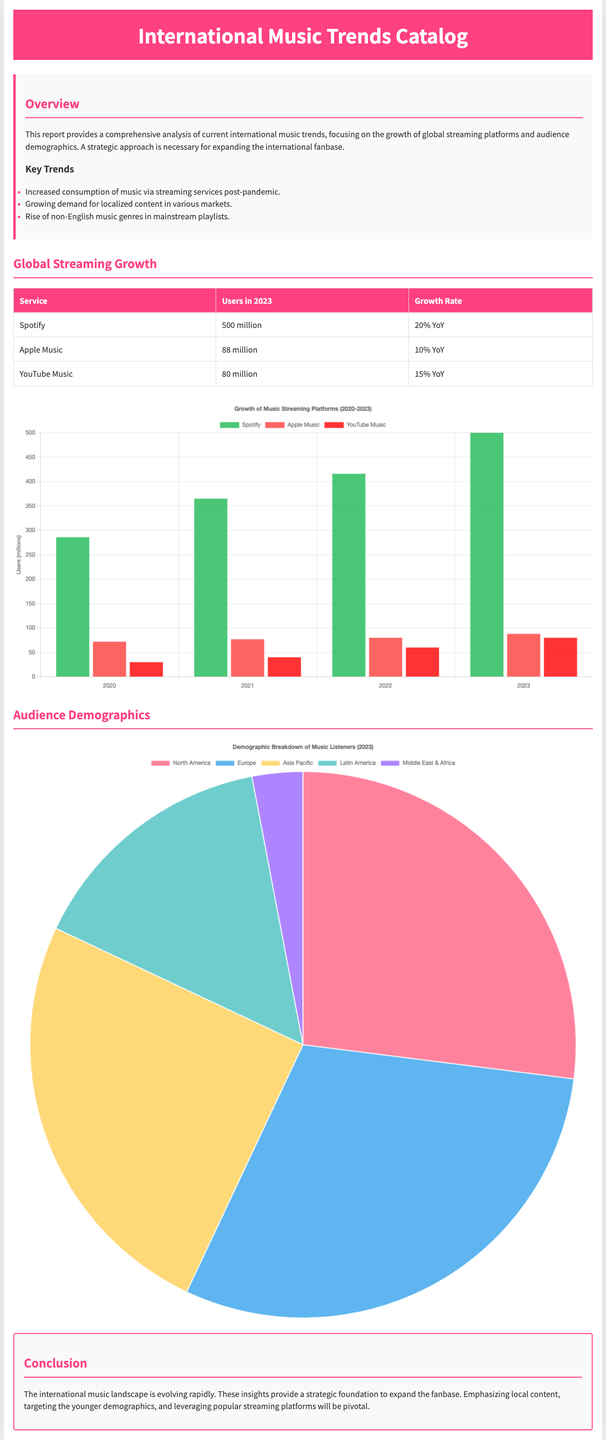What is the main focus of the report? The main focus of the report is on the growth of global streaming platforms and audience demographics.
Answer: Growth of global streaming platforms and audience demographics How many users does Spotify have in 2023? The document states that Spotify has 500 million users in 2023.
Answer: 500 million What is the growth rate for YouTube Music? The growth rate for YouTube Music is 15% YoY.
Answer: 15% YoY Which region has the largest demographic share of music listeners? The largest demographic share of music listeners is in Europe, with 30%.
Answer: Europe What was the number of Apple Music users in 2020? The document shows that Apple Music had 72 million users in 2020.
Answer: 72 million What trend is increasing post-pandemic according to the report? The report mentions an increased consumption of music via streaming services post-pandemic.
Answer: Increased consumption of music via streaming services What color represents YouTube Music in the streaming growth chart? YouTube Music is represented by the color red in the streaming growth chart.
Answer: Red What is the conclusion provided in the report? The conclusion emphasizes expanding the fanbase by leveraging popular streaming platforms and targeting younger demographics.
Answer: Expanding the fanbase by leveraging popular streaming platforms What is the title of the pie chart in the demographics section? The title of the pie chart is "Demographic Breakdown of Music Listeners (2023)".
Answer: Demographic Breakdown of Music Listeners (2023) 